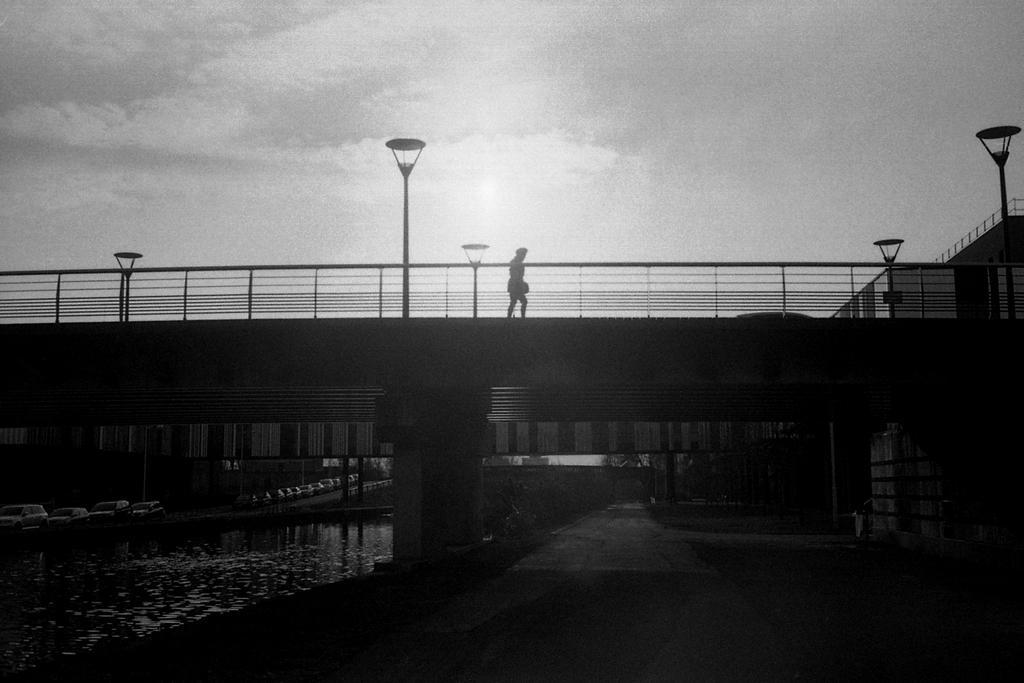Please provide a concise description of this image. This is a black and white image. I can see the streetlights and a person walking on a bridge. At the bottom left side of the image, there are vehicles on the road and I can see water. At the bottom right side of the image, there is a pathway. In the background, I can see the sky. 